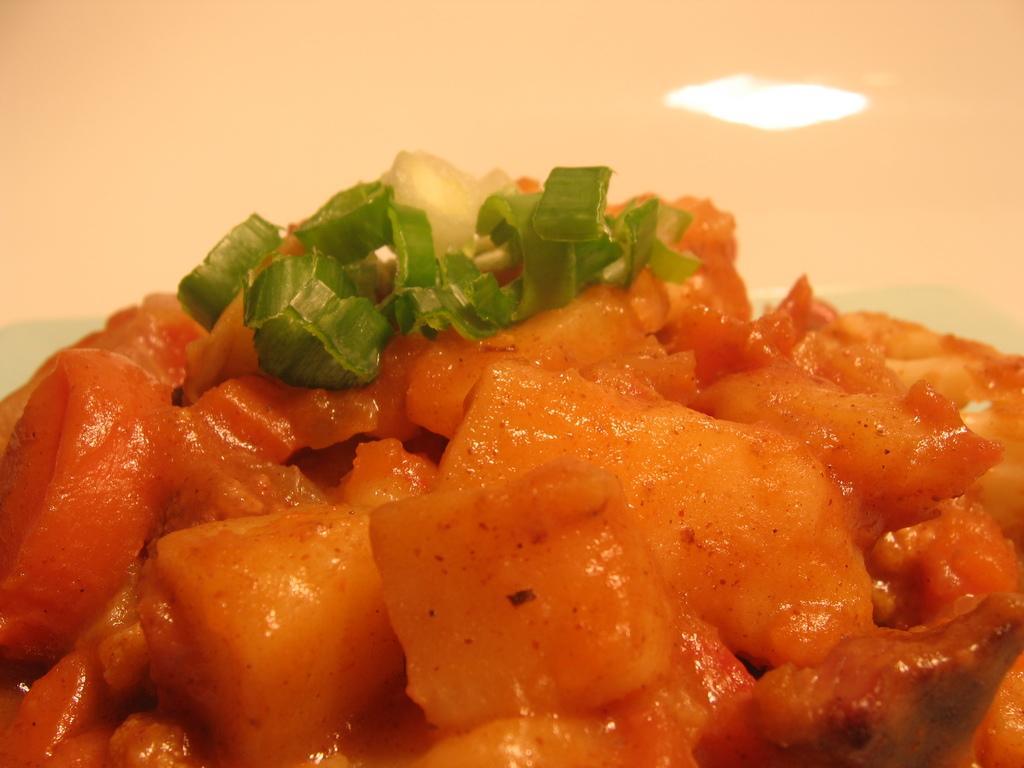Please provide a concise description of this image. This is a zoomed in picture. In the foreground we can see some food item. In the background there is a light. 